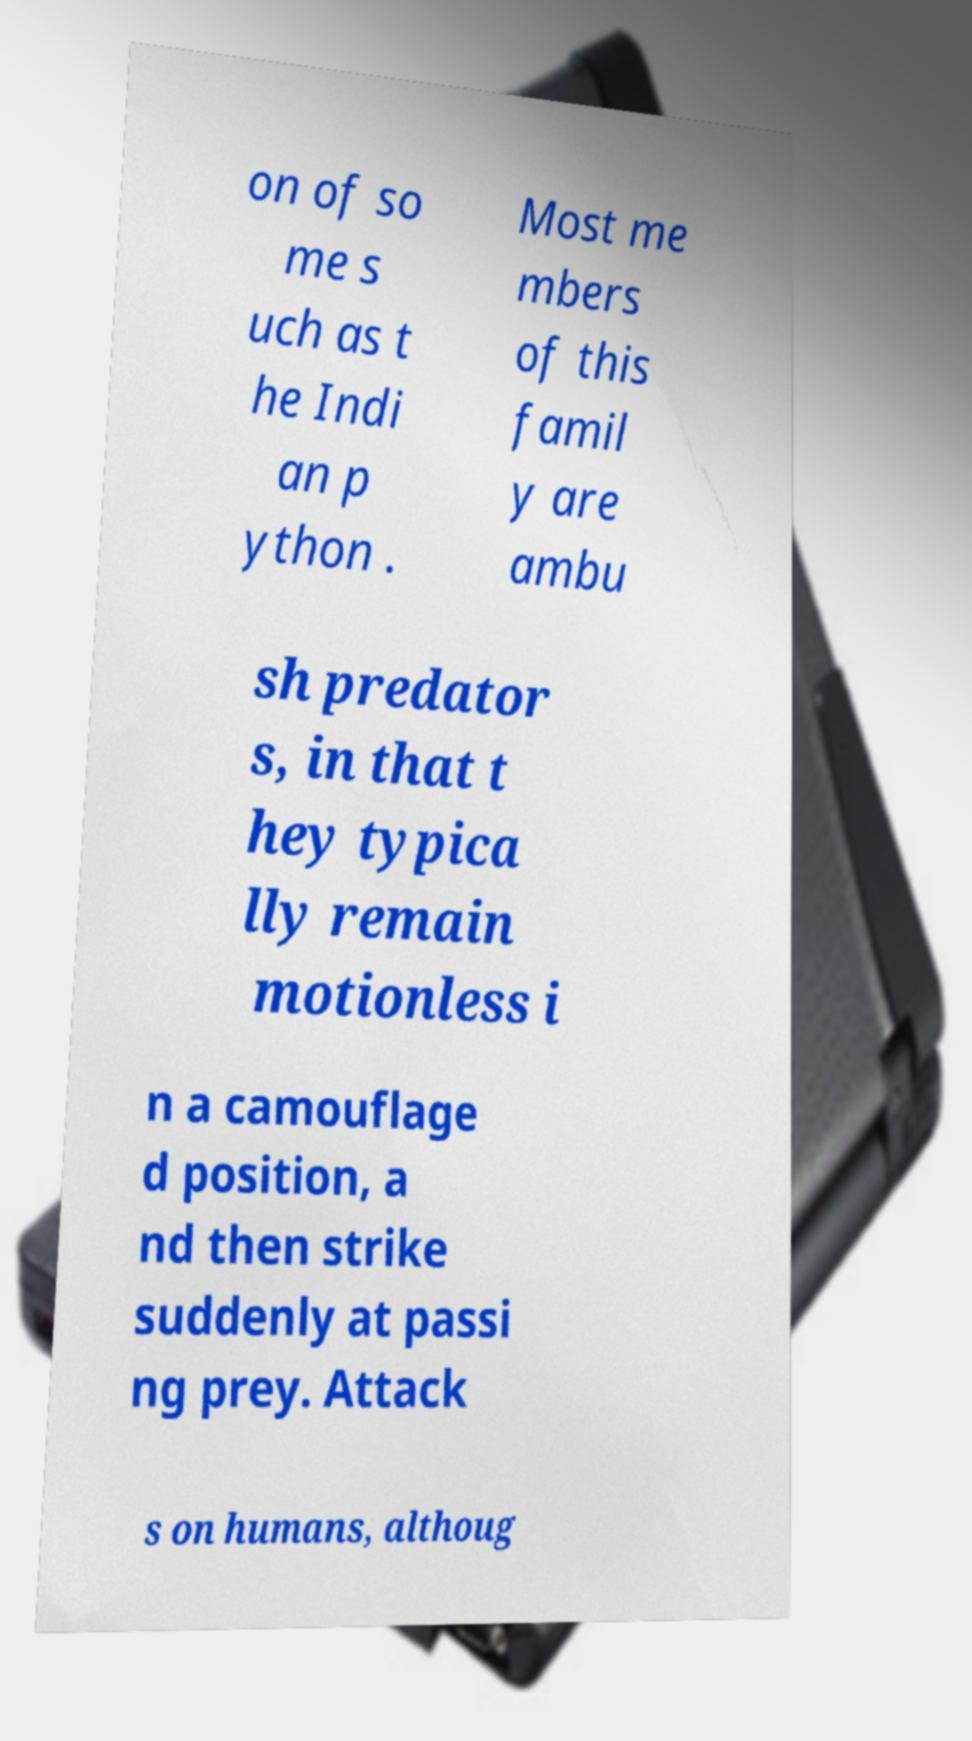Can you read and provide the text displayed in the image?This photo seems to have some interesting text. Can you extract and type it out for me? on of so me s uch as t he Indi an p ython . Most me mbers of this famil y are ambu sh predator s, in that t hey typica lly remain motionless i n a camouflage d position, a nd then strike suddenly at passi ng prey. Attack s on humans, althoug 